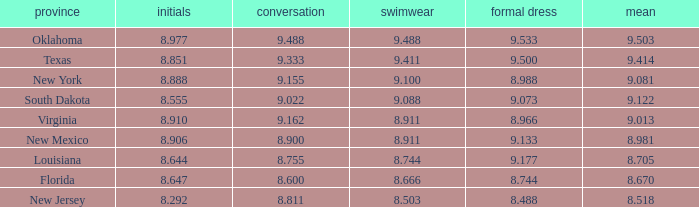 what's the swimsuit where average is 8.670 8.666. 